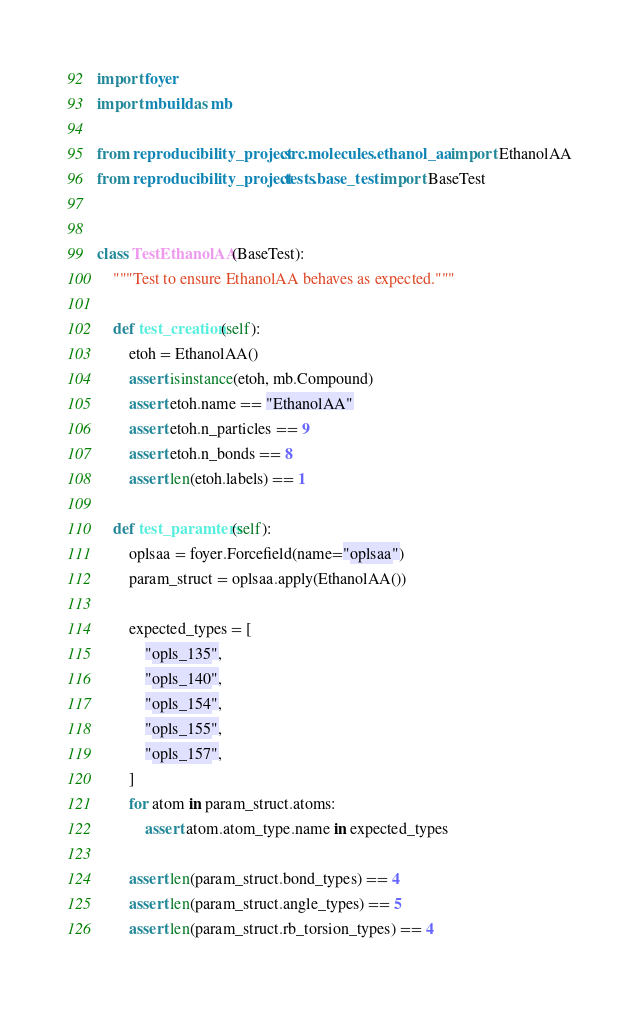Convert code to text. <code><loc_0><loc_0><loc_500><loc_500><_Python_>import foyer
import mbuild as mb

from reproducibility_project.src.molecules.ethanol_aa import EthanolAA
from reproducibility_project.tests.base_test import BaseTest


class TestEthanolAA(BaseTest):
    """Test to ensure EthanolAA behaves as expected."""

    def test_creation(self):
        etoh = EthanolAA()
        assert isinstance(etoh, mb.Compound)
        assert etoh.name == "EthanolAA"
        assert etoh.n_particles == 9
        assert etoh.n_bonds == 8
        assert len(etoh.labels) == 1

    def test_paramters(self):
        oplsaa = foyer.Forcefield(name="oplsaa")
        param_struct = oplsaa.apply(EthanolAA())

        expected_types = [
            "opls_135",
            "opls_140",
            "opls_154",
            "opls_155",
            "opls_157",
        ]
        for atom in param_struct.atoms:
            assert atom.atom_type.name in expected_types

        assert len(param_struct.bond_types) == 4
        assert len(param_struct.angle_types) == 5
        assert len(param_struct.rb_torsion_types) == 4
</code> 